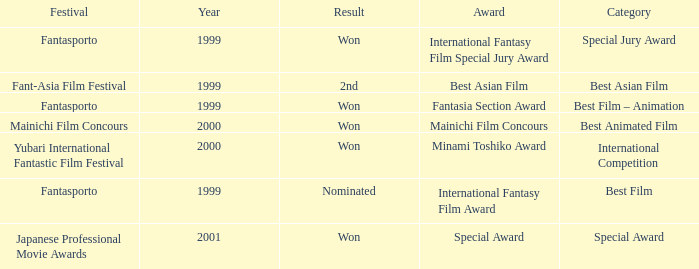What is the average year of the Fantasia Section Award? 1999.0. 